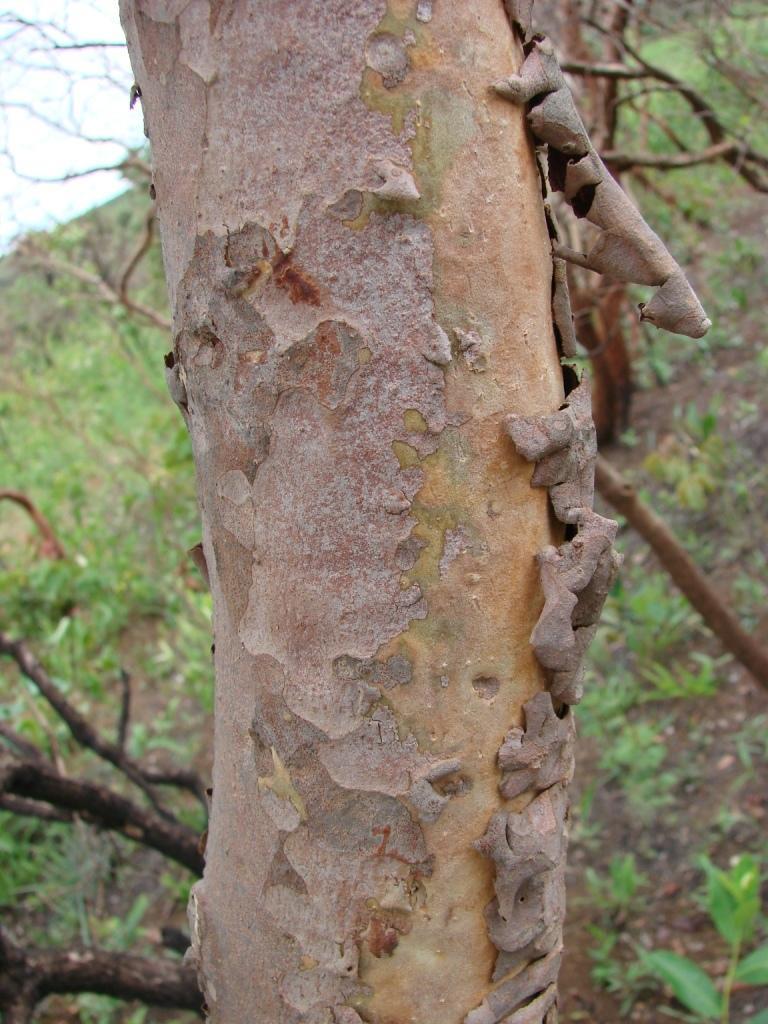Could you give a brief overview of what you see in this image? The picture I can see the tree trunk. The background of the image is slightly blurred, where we can see trees on the hills and I can see the sky. 